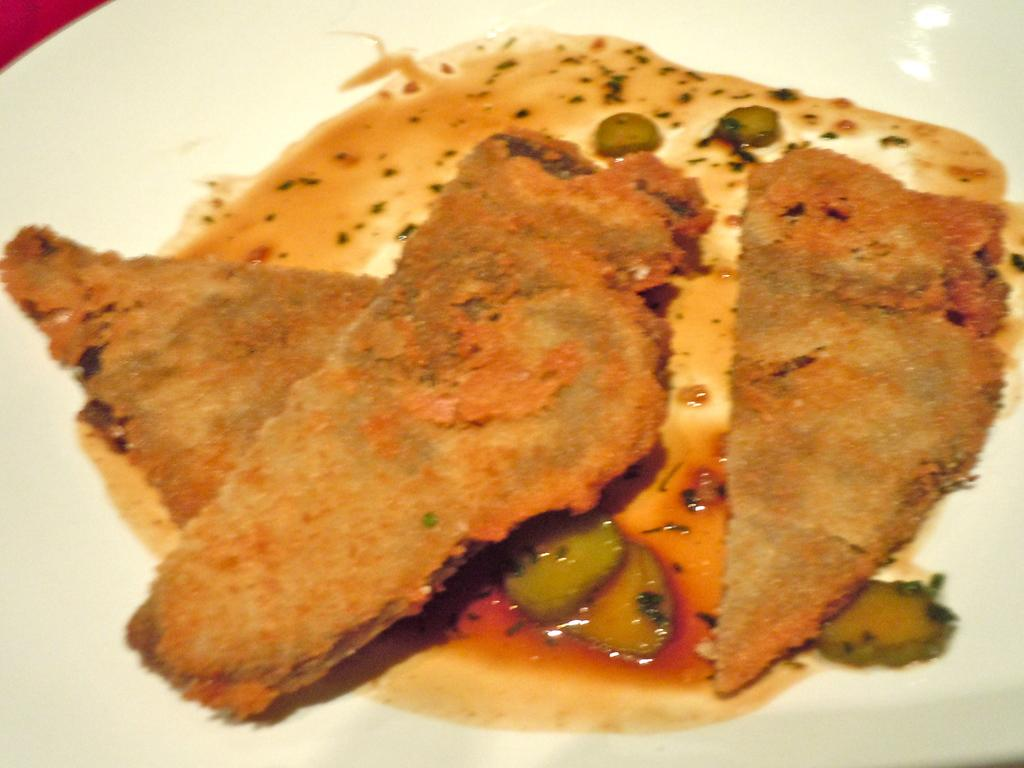What is present on the plate in the image? There are food items on the plate in the image. Is there anything else on the plate besides the food items? Yes, there is sauce on the plate. What type of sign can be seen on the ship in the image? There is no ship or sign present in the image. How is the hose connected to the plate in the image? There is no hose present in the image. 